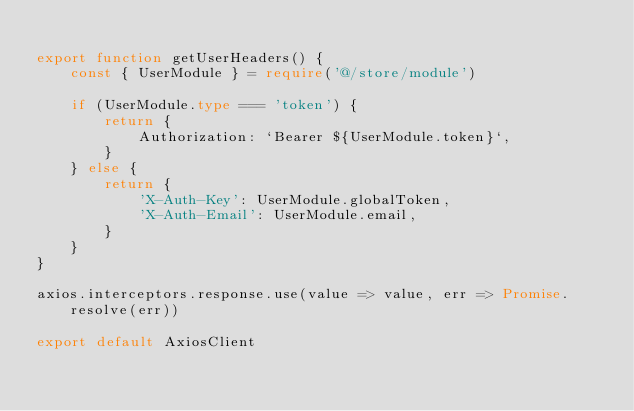Convert code to text. <code><loc_0><loc_0><loc_500><loc_500><_TypeScript_>
export function getUserHeaders() {
    const { UserModule } = require('@/store/module')

    if (UserModule.type === 'token') {
        return {
            Authorization: `Bearer ${UserModule.token}`,
        }
    } else {
        return {
            'X-Auth-Key': UserModule.globalToken,
            'X-Auth-Email': UserModule.email,
        }
    }
}

axios.interceptors.response.use(value => value, err => Promise.resolve(err))

export default AxiosClient
</code> 